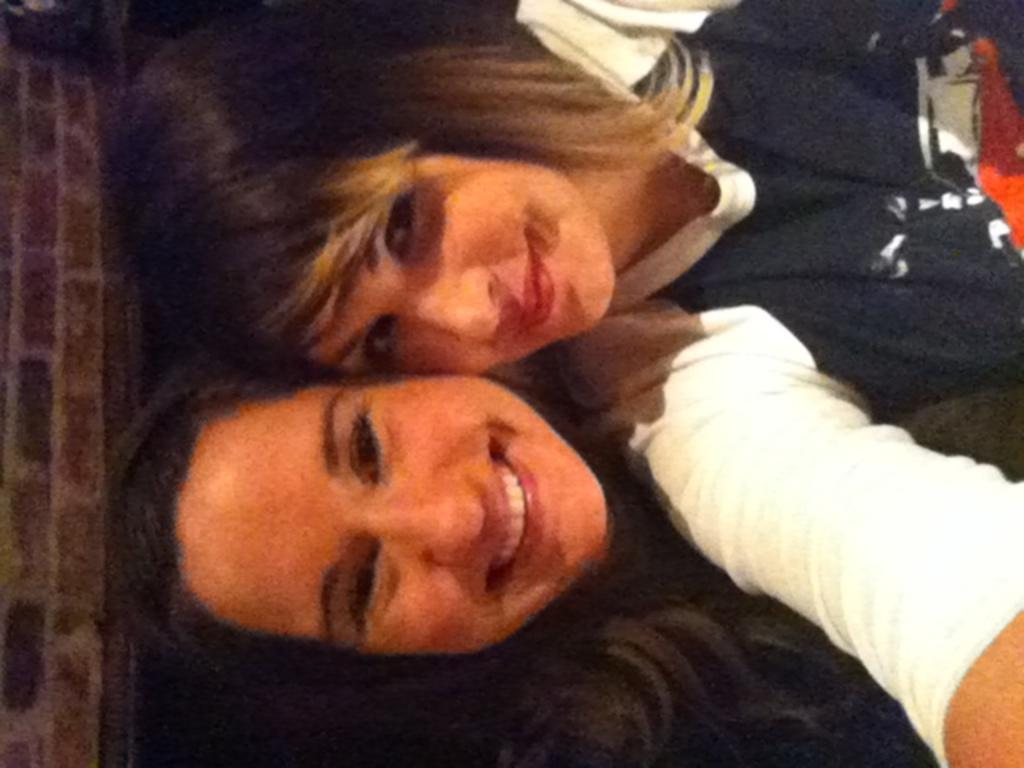How many people are in the image? There are two women in the image. What are the women doing in the image? The women are smiling and posing for the picture. What can be seen on the left side of the image? There is a wall on the left side of the image. What type of note can be seen on the grass near the seashore in the image? There is no grass, seashore, or note present in the image; it features two women smiling and posing for a picture with a wall on the left side. 